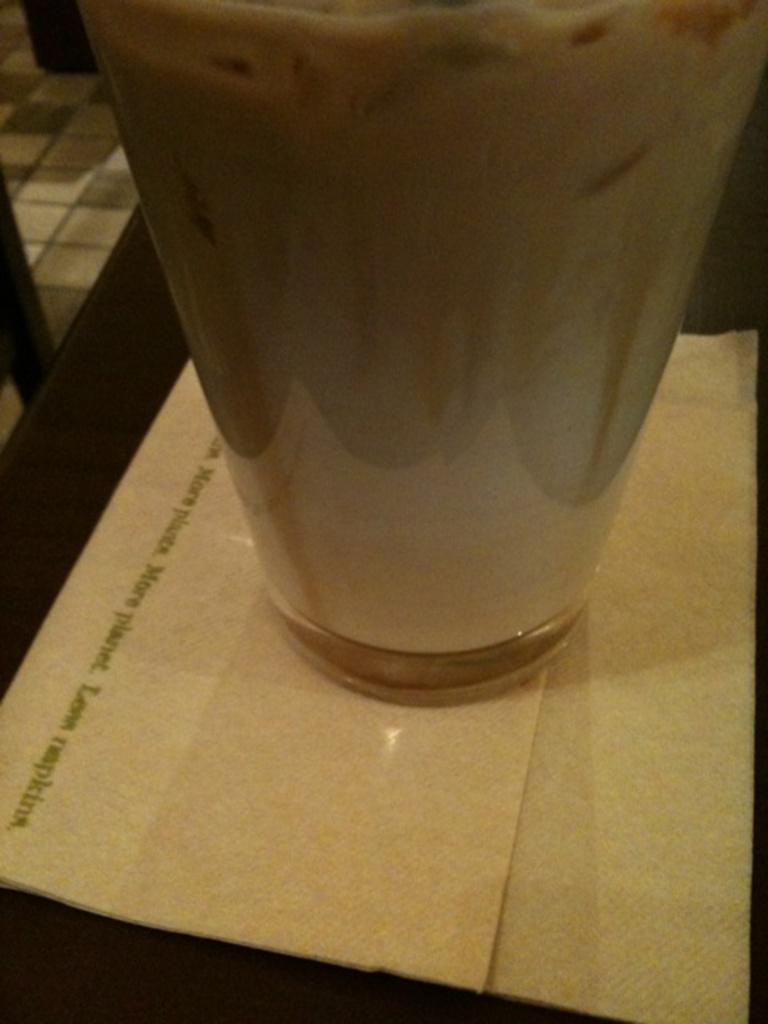Describe this image in one or two sentences. In this image I can see a table, above the table there is a tissue paper and glass. At the top left side of the image I can see a tile floor.   